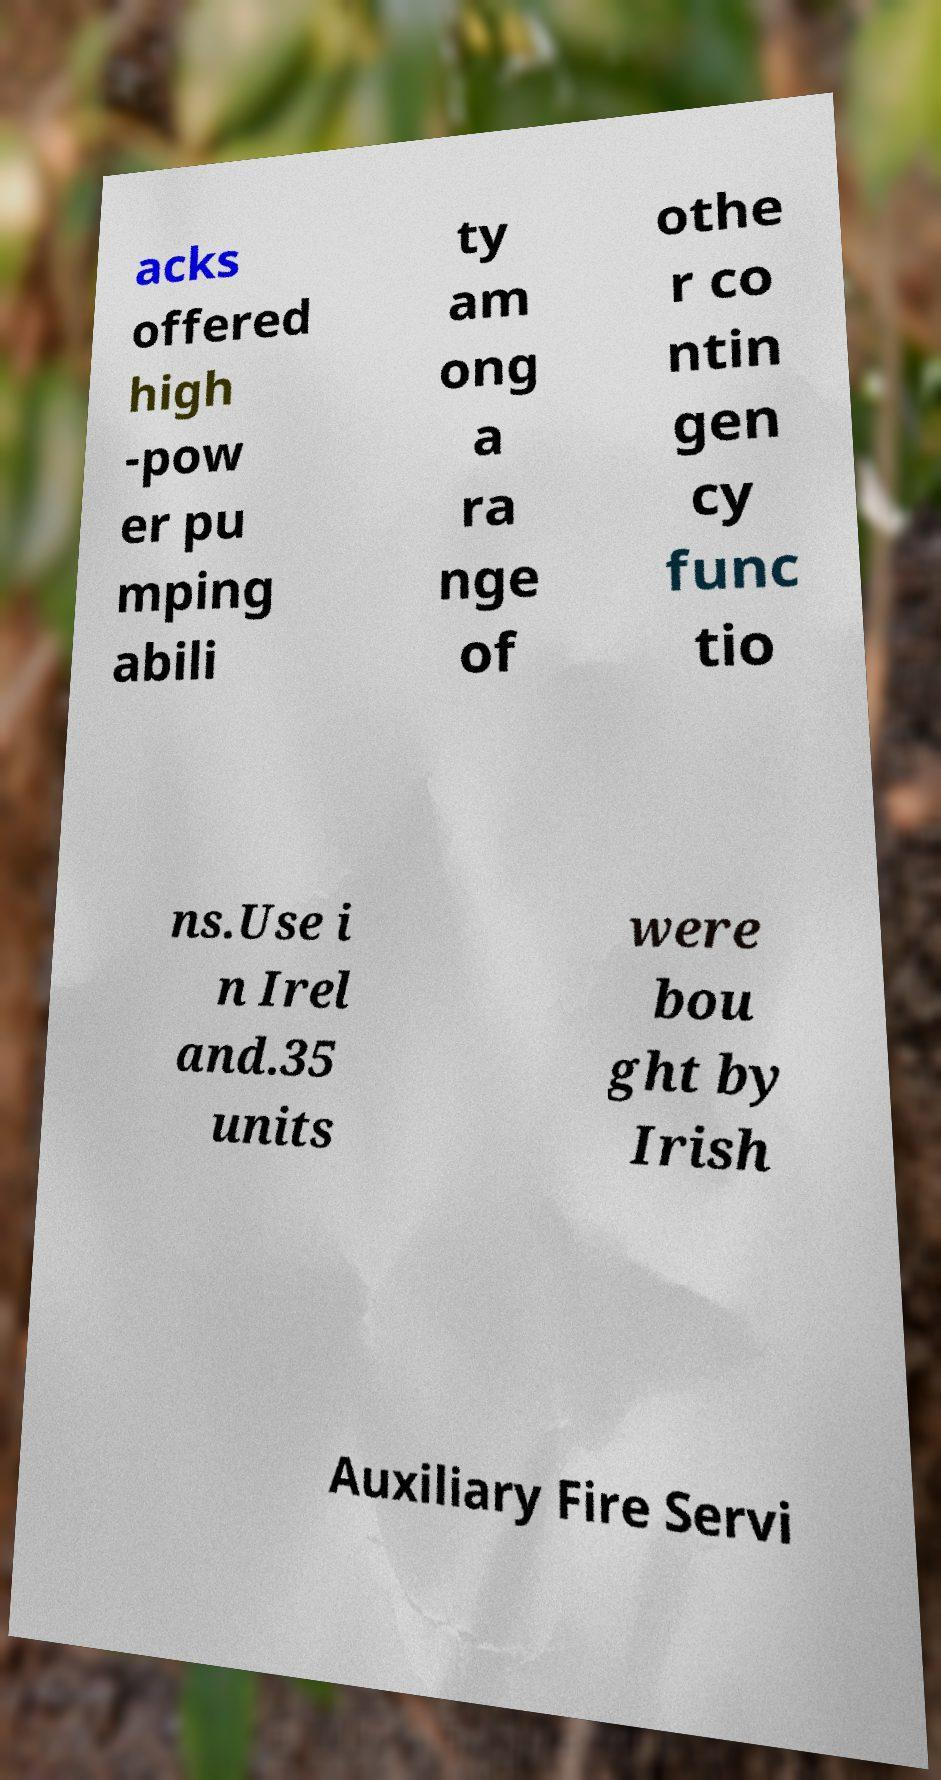Please identify and transcribe the text found in this image. acks offered high -pow er pu mping abili ty am ong a ra nge of othe r co ntin gen cy func tio ns.Use i n Irel and.35 units were bou ght by Irish Auxiliary Fire Servi 